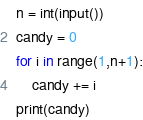Convert code to text. <code><loc_0><loc_0><loc_500><loc_500><_Python_>n = int(input())
candy = 0
for i in range(1,n+1):
    candy += i
print(candy)</code> 